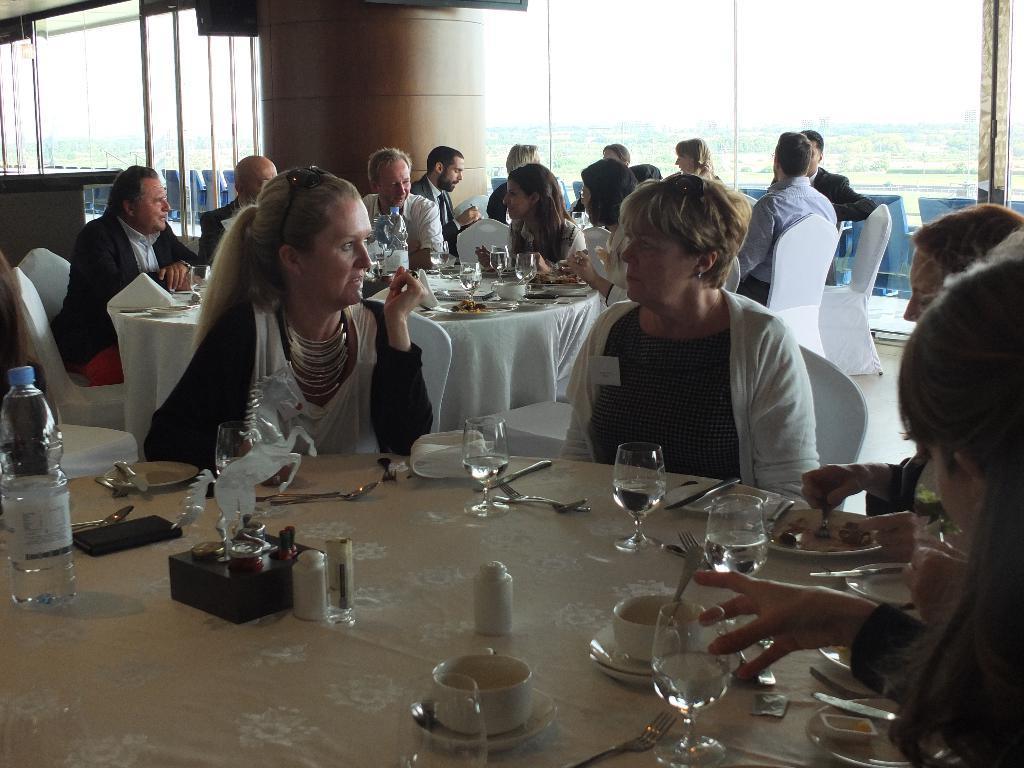How would you summarize this image in a sentence or two? In this picture i could see some persons around the dining tables and having a dine together. On dining table there are some wine glasses, forks, spoons, knives, pepper and salt bottles, water bottles, mobile phones and a horse statue on the table and there are cup and saucers too. 